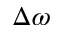Convert formula to latex. <formula><loc_0><loc_0><loc_500><loc_500>\Delta \omega</formula> 